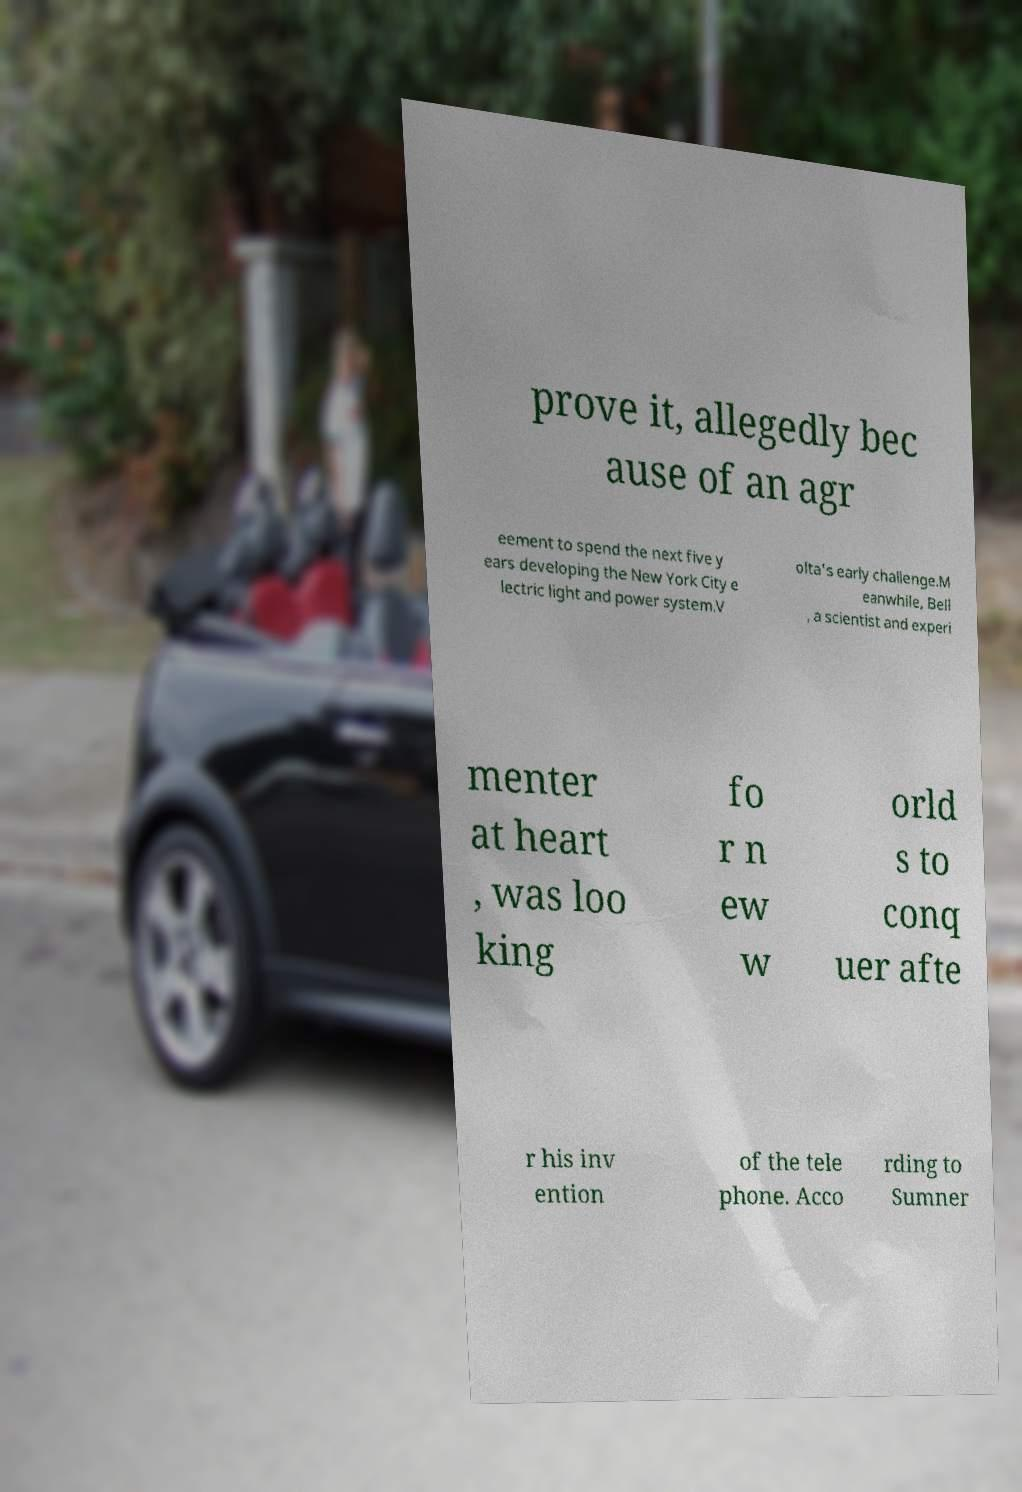Please read and relay the text visible in this image. What does it say? prove it, allegedly bec ause of an agr eement to spend the next five y ears developing the New York City e lectric light and power system.V olta's early challenge.M eanwhile, Bell , a scientist and experi menter at heart , was loo king fo r n ew w orld s to conq uer afte r his inv ention of the tele phone. Acco rding to Sumner 